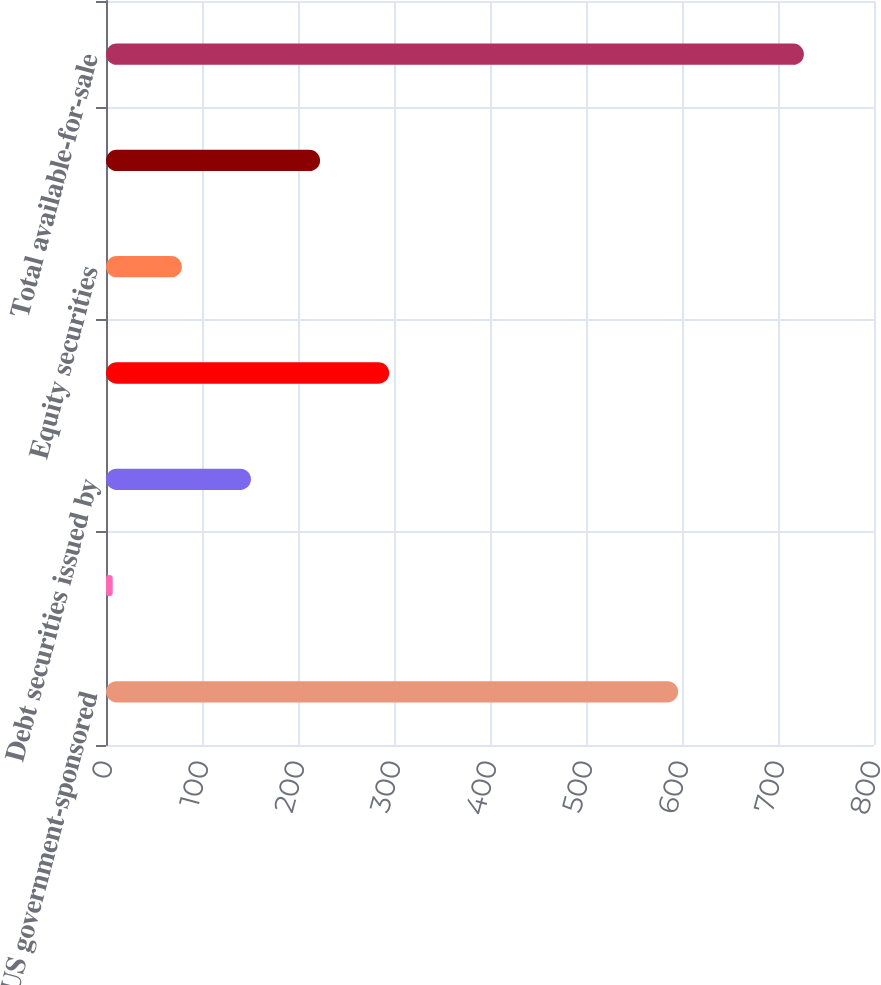Convert chart. <chart><loc_0><loc_0><loc_500><loc_500><bar_chart><fcel>US government-sponsored<fcel>Obligations of state and<fcel>Debt securities issued by<fcel>Corporate debt securities<fcel>Equity securities<fcel>Other primarily asset-backed<fcel>Total available-for-sale<nl><fcel>596<fcel>7<fcel>151<fcel>295<fcel>79<fcel>223<fcel>727<nl></chart> 